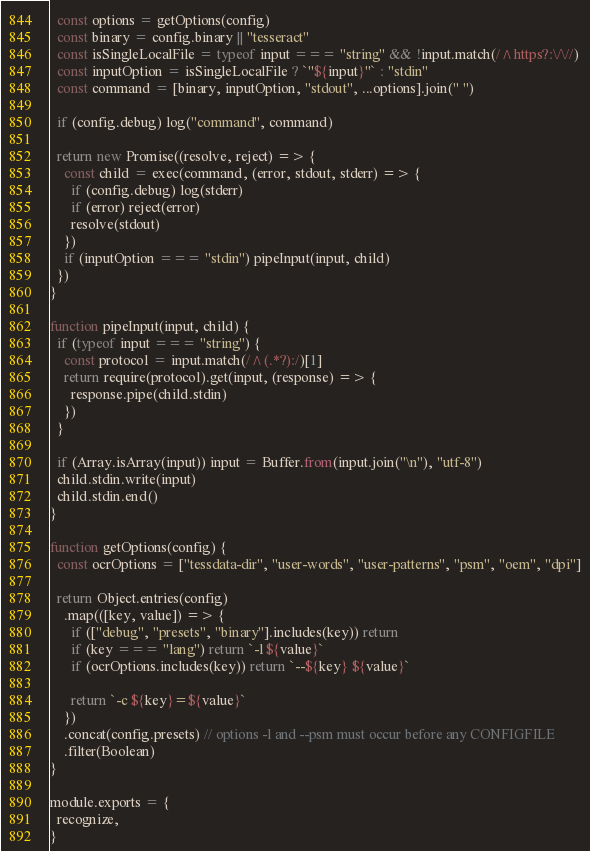<code> <loc_0><loc_0><loc_500><loc_500><_JavaScript_>  const options = getOptions(config)
  const binary = config.binary || "tesseract"
  const isSingleLocalFile = typeof input === "string" && !input.match(/^https?:\/\//)
  const inputOption = isSingleLocalFile ? `"${input}"` : "stdin"
  const command = [binary, inputOption, "stdout", ...options].join(" ")

  if (config.debug) log("command", command)

  return new Promise((resolve, reject) => {
    const child = exec(command, (error, stdout, stderr) => {
      if (config.debug) log(stderr)
      if (error) reject(error)
      resolve(stdout)
    })
    if (inputOption === "stdin") pipeInput(input, child)
  })
}

function pipeInput(input, child) {
  if (typeof input === "string") {
    const protocol = input.match(/^(.*?):/)[1]
    return require(protocol).get(input, (response) => {
      response.pipe(child.stdin)
    })
  }

  if (Array.isArray(input)) input = Buffer.from(input.join("\n"), "utf-8")
  child.stdin.write(input)
  child.stdin.end()
}

function getOptions(config) {
  const ocrOptions = ["tessdata-dir", "user-words", "user-patterns", "psm", "oem", "dpi"]

  return Object.entries(config)
    .map(([key, value]) => {
      if (["debug", "presets", "binary"].includes(key)) return
      if (key === "lang") return `-l ${value}`
      if (ocrOptions.includes(key)) return `--${key} ${value}`

      return `-c ${key}=${value}`
    })
    .concat(config.presets) // options -l and --psm must occur before any CONFIGFILE
    .filter(Boolean)
}

module.exports = {
  recognize,
}
</code> 